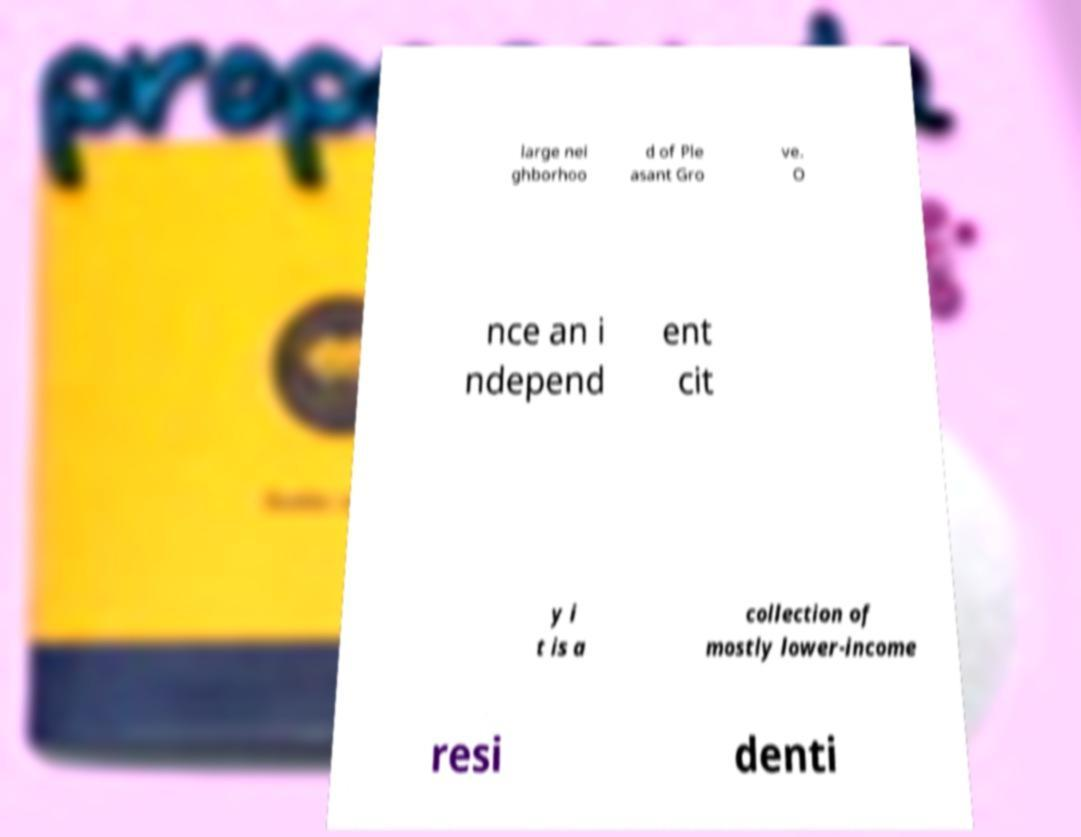There's text embedded in this image that I need extracted. Can you transcribe it verbatim? large nei ghborhoo d of Ple asant Gro ve. O nce an i ndepend ent cit y i t is a collection of mostly lower-income resi denti 